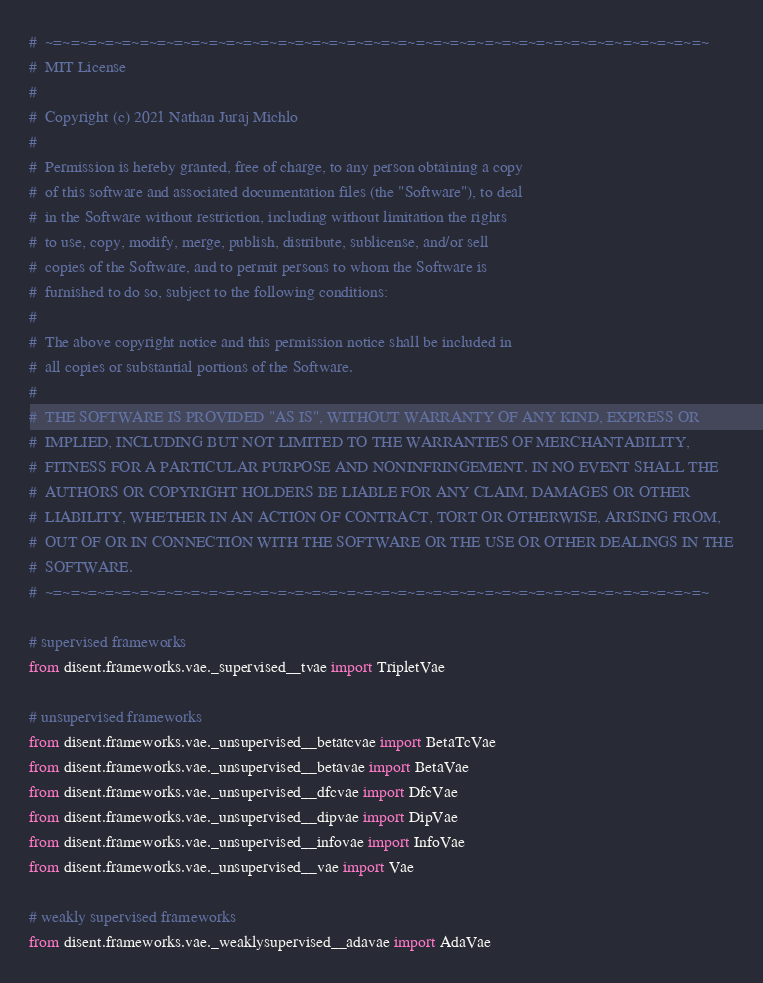Convert code to text. <code><loc_0><loc_0><loc_500><loc_500><_Python_>#  ~=~=~=~=~=~=~=~=~=~=~=~=~=~=~=~=~=~=~=~=~=~=~=~=~=~=~=~=~=~=~=~=~=~=~=~=~=~=~
#  MIT License
#
#  Copyright (c) 2021 Nathan Juraj Michlo
#
#  Permission is hereby granted, free of charge, to any person obtaining a copy
#  of this software and associated documentation files (the "Software"), to deal
#  in the Software without restriction, including without limitation the rights
#  to use, copy, modify, merge, publish, distribute, sublicense, and/or sell
#  copies of the Software, and to permit persons to whom the Software is
#  furnished to do so, subject to the following conditions:
#
#  The above copyright notice and this permission notice shall be included in
#  all copies or substantial portions of the Software.
#
#  THE SOFTWARE IS PROVIDED "AS IS", WITHOUT WARRANTY OF ANY KIND, EXPRESS OR
#  IMPLIED, INCLUDING BUT NOT LIMITED TO THE WARRANTIES OF MERCHANTABILITY,
#  FITNESS FOR A PARTICULAR PURPOSE AND NONINFRINGEMENT. IN NO EVENT SHALL THE
#  AUTHORS OR COPYRIGHT HOLDERS BE LIABLE FOR ANY CLAIM, DAMAGES OR OTHER
#  LIABILITY, WHETHER IN AN ACTION OF CONTRACT, TORT OR OTHERWISE, ARISING FROM,
#  OUT OF OR IN CONNECTION WITH THE SOFTWARE OR THE USE OR OTHER DEALINGS IN THE
#  SOFTWARE.
#  ~=~=~=~=~=~=~=~=~=~=~=~=~=~=~=~=~=~=~=~=~=~=~=~=~=~=~=~=~=~=~=~=~=~=~=~=~=~=~

# supervised frameworks
from disent.frameworks.vae._supervised__tvae import TripletVae

# unsupervised frameworks
from disent.frameworks.vae._unsupervised__betatcvae import BetaTcVae
from disent.frameworks.vae._unsupervised__betavae import BetaVae
from disent.frameworks.vae._unsupervised__dfcvae import DfcVae
from disent.frameworks.vae._unsupervised__dipvae import DipVae
from disent.frameworks.vae._unsupervised__infovae import InfoVae
from disent.frameworks.vae._unsupervised__vae import Vae

# weakly supervised frameworks
from disent.frameworks.vae._weaklysupervised__adavae import AdaVae
</code> 